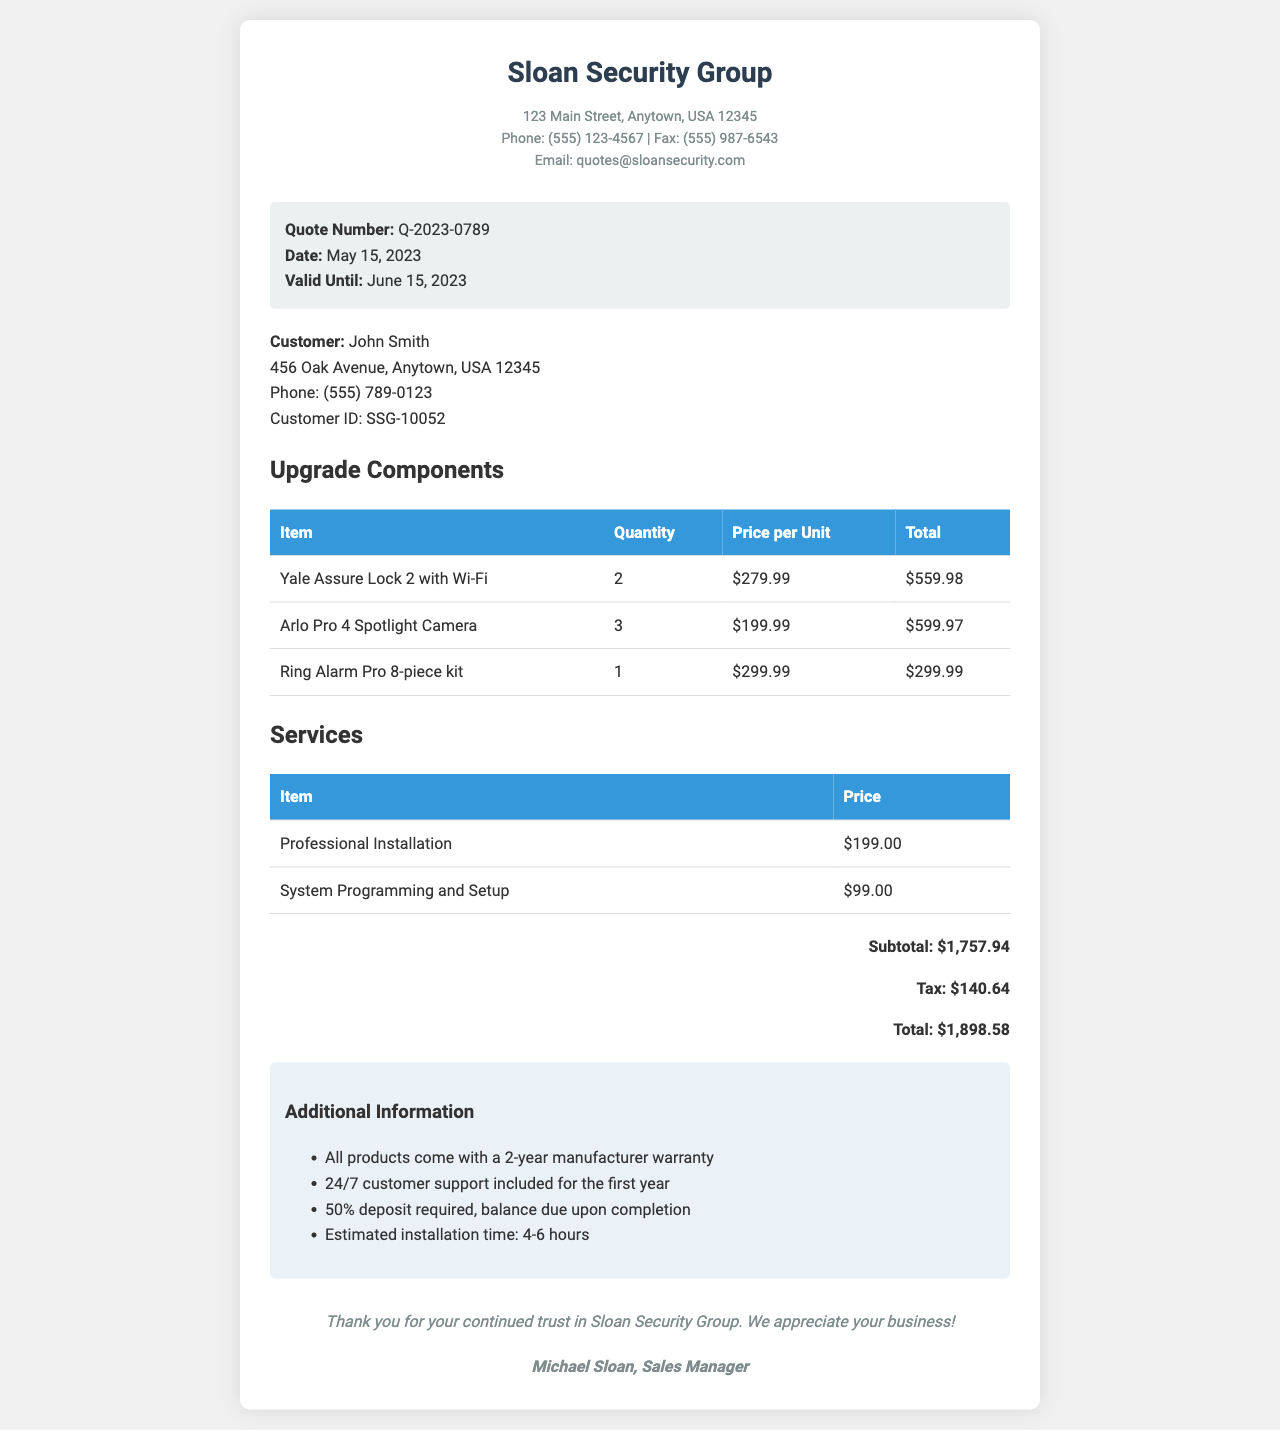what is the quote number? The quote number is listed as Q-2023-0789 in the document.
Answer: Q-2023-0789 what is the total cost? The total cost is provided at the end of the document as $1,898.58.
Answer: $1,898.58 how many Yale Assure Lock 2 with Wi-Fi units are included? The document specifies that there are 2 units of Yale Assure Lock 2 with Wi-Fi.
Answer: 2 what is the price for professional installation? The document states that the price for professional installation is $199.00.
Answer: $199.00 what is the estimated installation time? The estimated installation time mentioned in the document is 4-6 hours.
Answer: 4-6 hours who is the sales manager? The document lists Michael Sloan as the sales manager.
Answer: Michael Sloan what is the tax amount? The tax amount calculated in the document is $140.64.
Answer: $140.64 how long is the manufacturer warranty? According to the additional information, all products come with a 2-year manufacturer warranty.
Answer: 2 years when is the quote valid until? The document indicates that the quote is valid until June 15, 2023.
Answer: June 15, 2023 